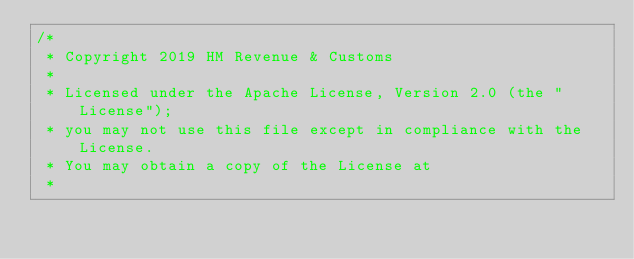<code> <loc_0><loc_0><loc_500><loc_500><_Scala_>/*
 * Copyright 2019 HM Revenue & Customs
 *
 * Licensed under the Apache License, Version 2.0 (the "License");
 * you may not use this file except in compliance with the License.
 * You may obtain a copy of the License at
 *</code> 